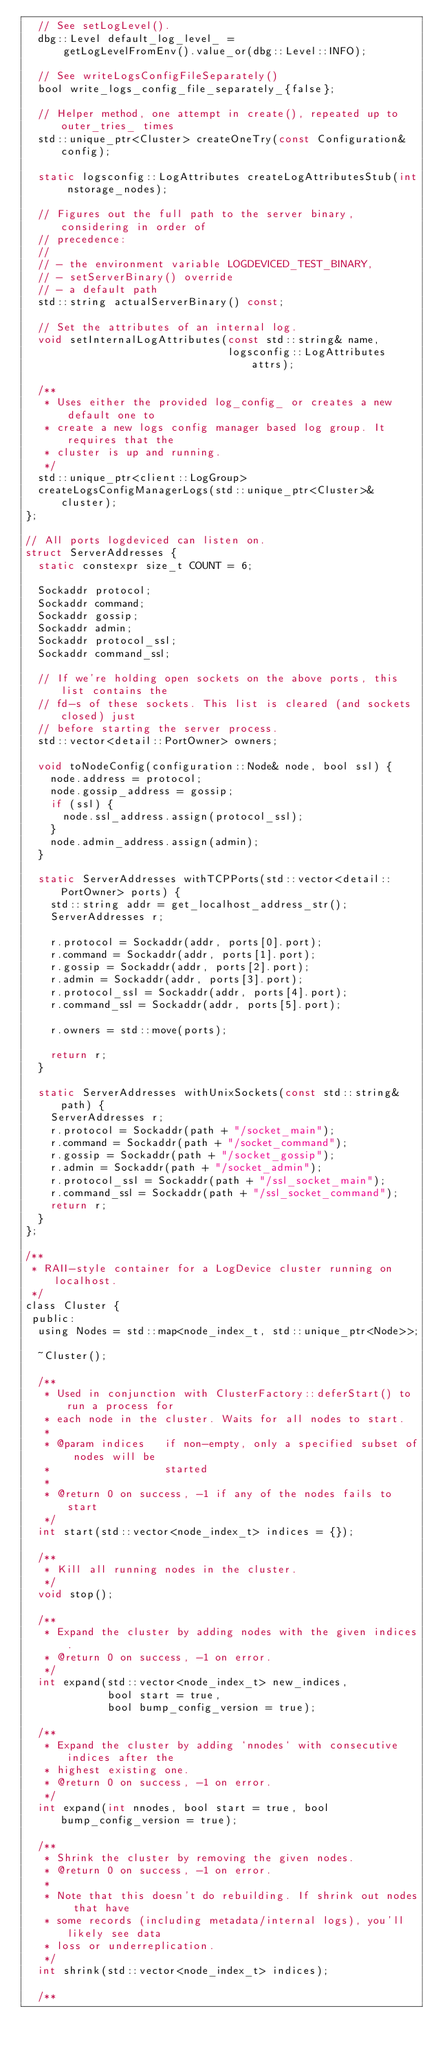Convert code to text. <code><loc_0><loc_0><loc_500><loc_500><_C_>  // See setLogLevel().
  dbg::Level default_log_level_ =
      getLogLevelFromEnv().value_or(dbg::Level::INFO);

  // See writeLogsConfigFileSeparately()
  bool write_logs_config_file_separately_{false};

  // Helper method, one attempt in create(), repeated up to outer_tries_ times
  std::unique_ptr<Cluster> createOneTry(const Configuration& config);

  static logsconfig::LogAttributes createLogAttributesStub(int nstorage_nodes);

  // Figures out the full path to the server binary, considering in order of
  // precedence:
  //
  // - the environment variable LOGDEVICED_TEST_BINARY,
  // - setServerBinary() override
  // - a default path
  std::string actualServerBinary() const;

  // Set the attributes of an internal log.
  void setInternalLogAttributes(const std::string& name,
                                logsconfig::LogAttributes attrs);

  /**
   * Uses either the provided log_config_ or creates a new default one to
   * create a new logs config manager based log group. It requires that the
   * cluster is up and running.
   */
  std::unique_ptr<client::LogGroup>
  createLogsConfigManagerLogs(std::unique_ptr<Cluster>& cluster);
};

// All ports logdeviced can listen on.
struct ServerAddresses {
  static constexpr size_t COUNT = 6;

  Sockaddr protocol;
  Sockaddr command;
  Sockaddr gossip;
  Sockaddr admin;
  Sockaddr protocol_ssl;
  Sockaddr command_ssl;

  // If we're holding open sockets on the above ports, this list contains the
  // fd-s of these sockets. This list is cleared (and sockets closed) just
  // before starting the server process.
  std::vector<detail::PortOwner> owners;

  void toNodeConfig(configuration::Node& node, bool ssl) {
    node.address = protocol;
    node.gossip_address = gossip;
    if (ssl) {
      node.ssl_address.assign(protocol_ssl);
    }
    node.admin_address.assign(admin);
  }

  static ServerAddresses withTCPPorts(std::vector<detail::PortOwner> ports) {
    std::string addr = get_localhost_address_str();
    ServerAddresses r;

    r.protocol = Sockaddr(addr, ports[0].port);
    r.command = Sockaddr(addr, ports[1].port);
    r.gossip = Sockaddr(addr, ports[2].port);
    r.admin = Sockaddr(addr, ports[3].port);
    r.protocol_ssl = Sockaddr(addr, ports[4].port);
    r.command_ssl = Sockaddr(addr, ports[5].port);

    r.owners = std::move(ports);

    return r;
  }

  static ServerAddresses withUnixSockets(const std::string& path) {
    ServerAddresses r;
    r.protocol = Sockaddr(path + "/socket_main");
    r.command = Sockaddr(path + "/socket_command");
    r.gossip = Sockaddr(path + "/socket_gossip");
    r.admin = Sockaddr(path + "/socket_admin");
    r.protocol_ssl = Sockaddr(path + "/ssl_socket_main");
    r.command_ssl = Sockaddr(path + "/ssl_socket_command");
    return r;
  }
};

/**
 * RAII-style container for a LogDevice cluster running on localhost.
 */
class Cluster {
 public:
  using Nodes = std::map<node_index_t, std::unique_ptr<Node>>;

  ~Cluster();

  /**
   * Used in conjunction with ClusterFactory::deferStart() to run a process for
   * each node in the cluster. Waits for all nodes to start.
   *
   * @param indices   if non-empty, only a specified subset of nodes will be
   *                  started
   *
   * @return 0 on success, -1 if any of the nodes fails to start
   */
  int start(std::vector<node_index_t> indices = {});

  /**
   * Kill all running nodes in the cluster.
   */
  void stop();

  /**
   * Expand the cluster by adding nodes with the given indices.
   * @return 0 on success, -1 on error.
   */
  int expand(std::vector<node_index_t> new_indices,
             bool start = true,
             bool bump_config_version = true);

  /**
   * Expand the cluster by adding `nnodes` with consecutive indices after the
   * highest existing one.
   * @return 0 on success, -1 on error.
   */
  int expand(int nnodes, bool start = true, bool bump_config_version = true);

  /**
   * Shrink the cluster by removing the given nodes.
   * @return 0 on success, -1 on error.
   *
   * Note that this doesn't do rebuilding. If shrink out nodes that have
   * some records (including metadata/internal logs), you'll likely see data
   * loss or underreplication.
   */
  int shrink(std::vector<node_index_t> indices);

  /**</code> 